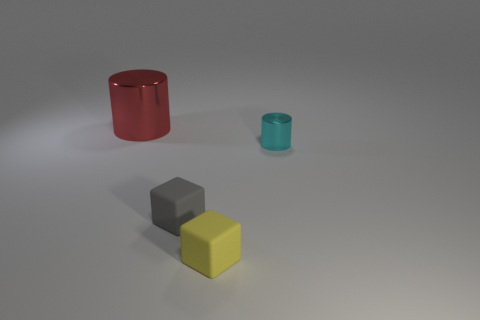There is a yellow cube; is it the same size as the shiny thing that is left of the cyan object?
Your answer should be compact. No. What size is the metal thing that is on the left side of the matte object that is on the right side of the gray rubber block that is left of the tiny yellow object?
Your answer should be very brief. Large. What number of small cyan objects are behind the gray cube?
Provide a succinct answer. 1. What material is the cylinder in front of the metal thing that is on the left side of the cyan thing?
Your answer should be very brief. Metal. Is there anything else that has the same size as the gray cube?
Offer a very short reply. Yes. Is the gray matte cube the same size as the red cylinder?
Provide a short and direct response. No. What number of objects are either cylinders to the right of the gray rubber block or metal cylinders in front of the big shiny object?
Keep it short and to the point. 1. Are there more tiny cubes behind the yellow matte thing than tiny metallic balls?
Your answer should be very brief. Yes. How many other things are there of the same shape as the cyan shiny thing?
Your answer should be very brief. 1. There is a thing that is both to the left of the yellow rubber object and in front of the small shiny cylinder; what is its material?
Ensure brevity in your answer.  Rubber. 